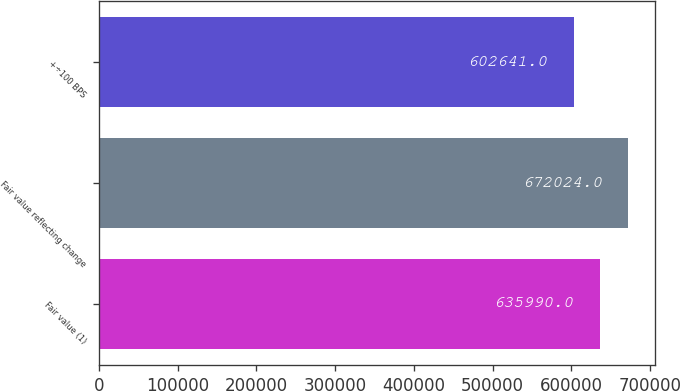Convert chart to OTSL. <chart><loc_0><loc_0><loc_500><loc_500><bar_chart><fcel>Fair value (1)<fcel>Fair value reflecting change<fcel>+÷100 BPS<nl><fcel>635990<fcel>672024<fcel>602641<nl></chart> 